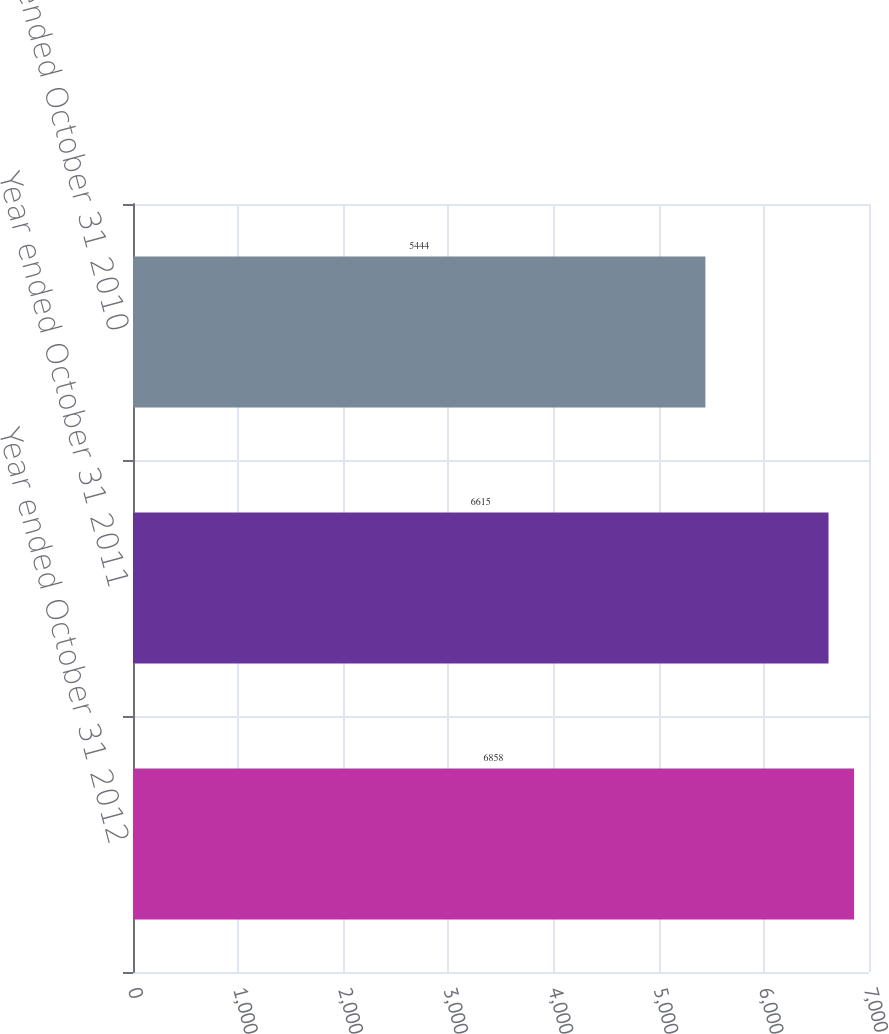<chart> <loc_0><loc_0><loc_500><loc_500><bar_chart><fcel>Year ended October 31 2012<fcel>Year ended October 31 2011<fcel>Year ended October 31 2010<nl><fcel>6858<fcel>6615<fcel>5444<nl></chart> 